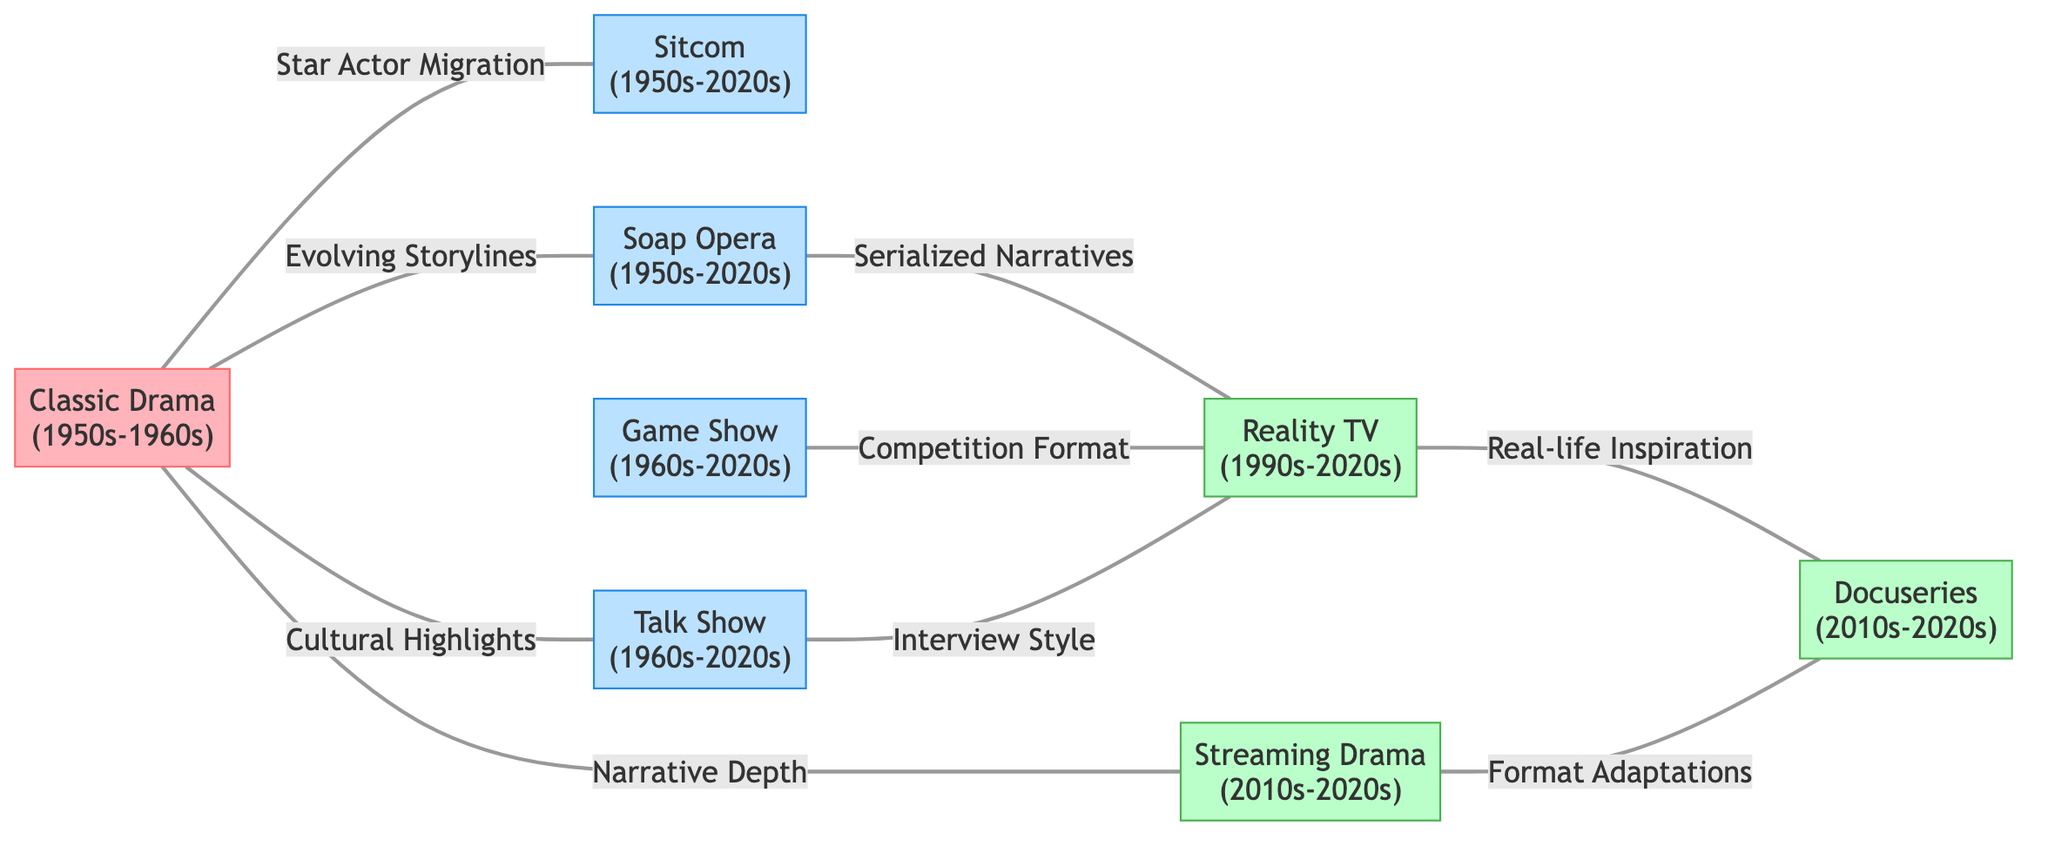What is the earliest era represented in the diagram? The earliest era represented in the diagram is from the "Classic Drama" node, which is labeled with "1950s-1960s." This indicates that the first genre shown began during this time frame.
Answer: 1950s-1960s How many nodes are in the diagram? By counting each unique television show genre listed in the data, we find there are eight nodes: Classic Drama, Sitcom, Soap Opera, Talk Show, Game Show, Reality TV, Streaming Drama, and Docuseries. Therefore, there are a total of eight nodes represented.
Answer: 8 Which genre is influenced by "Cultural Highlights"? The "Classic Drama" node connects to the "Talk Show" node with the influence noted as "Cultural Highlights." This demonstrates the relationship between these two genres based on how classic drama elements have impacted talk shows.
Answer: Talk Show What are the two genres influenced by "Serialized Narratives"? The "Soap Opera" node has edges connecting it to "Reality TV" indicating an influence from "Serialized Narratives." Thus, the two genres connected through this influence are Soap Opera and Reality TV.
Answer: Reality TV How many edges connect to "Reality TV"? From the diagram, we can see the connections as follows: "Soap Opera," "Game Show," and "Talk Show" all connect to "Reality TV." Counting these edges gives us a total of three direct influences leading into the Reality TV genre.
Answer: 3 Which show genres directly connect to "Docuseries"? The "Reality TV" and "Streaming Drama" nodes are both connected to the "Docuseries" node. Each connection indicates a specific influence: "Real-life Inspiration" from Reality TV and "Format Adaptations" from Streaming Drama.
Answer: Reality TV, Streaming Drama What type of influence connects "Classic Drama" to "Streaming Drama"? The edge connecting "Classic Drama" to "Streaming Drama" is described with "Narrative Depth." This indicates that the storytelling aspects of classic dramas have influenced the newer streaming drama format significantly.
Answer: Narrative Depth What type of television show format emerged in the 1990s? Looking at the diagram, the "Reality TV" genre began in the 1990s and it is clearly marked with its era. This highlights that Reality TV became a notable genre during that decade and continues to influence other formats.
Answer: Reality TV 